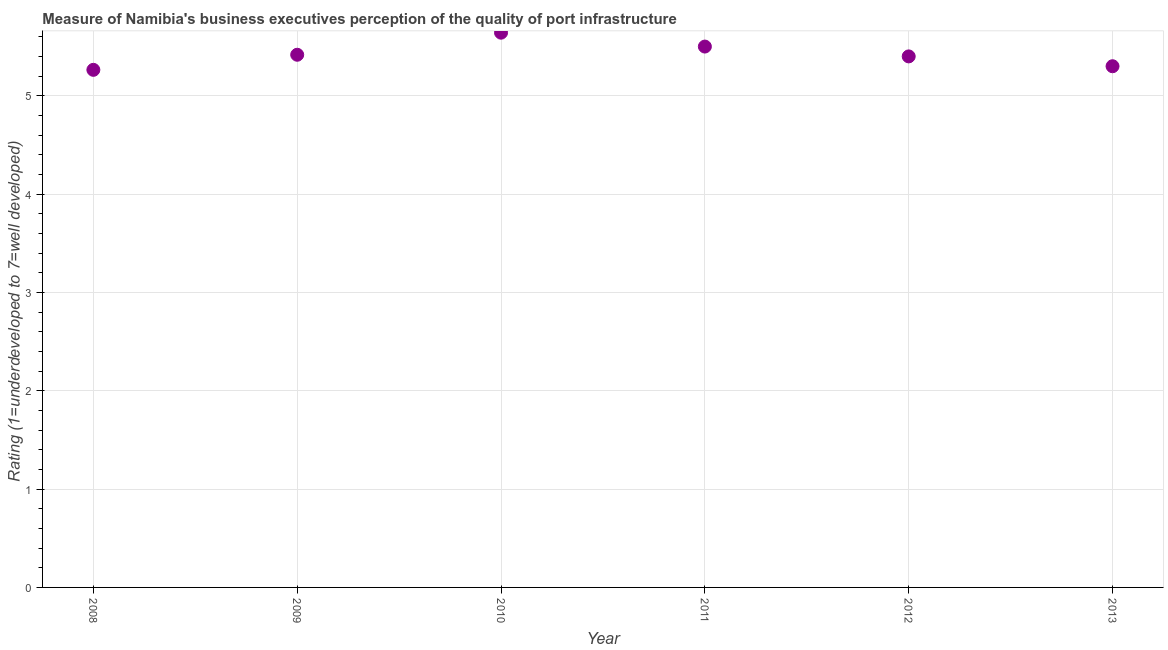What is the rating measuring quality of port infrastructure in 2009?
Ensure brevity in your answer.  5.42. Across all years, what is the maximum rating measuring quality of port infrastructure?
Your response must be concise. 5.64. Across all years, what is the minimum rating measuring quality of port infrastructure?
Your answer should be compact. 5.26. In which year was the rating measuring quality of port infrastructure maximum?
Keep it short and to the point. 2010. In which year was the rating measuring quality of port infrastructure minimum?
Offer a very short reply. 2008. What is the sum of the rating measuring quality of port infrastructure?
Your answer should be compact. 32.52. What is the difference between the rating measuring quality of port infrastructure in 2010 and 2012?
Your answer should be compact. 0.24. What is the average rating measuring quality of port infrastructure per year?
Provide a succinct answer. 5.42. What is the median rating measuring quality of port infrastructure?
Make the answer very short. 5.41. What is the ratio of the rating measuring quality of port infrastructure in 2008 to that in 2010?
Give a very brief answer. 0.93. Is the difference between the rating measuring quality of port infrastructure in 2010 and 2012 greater than the difference between any two years?
Provide a succinct answer. No. What is the difference between the highest and the second highest rating measuring quality of port infrastructure?
Your answer should be compact. 0.14. What is the difference between the highest and the lowest rating measuring quality of port infrastructure?
Ensure brevity in your answer.  0.38. In how many years, is the rating measuring quality of port infrastructure greater than the average rating measuring quality of port infrastructure taken over all years?
Keep it short and to the point. 2. What is the title of the graph?
Your answer should be very brief. Measure of Namibia's business executives perception of the quality of port infrastructure. What is the label or title of the X-axis?
Ensure brevity in your answer.  Year. What is the label or title of the Y-axis?
Give a very brief answer. Rating (1=underdeveloped to 7=well developed) . What is the Rating (1=underdeveloped to 7=well developed)  in 2008?
Your response must be concise. 5.26. What is the Rating (1=underdeveloped to 7=well developed)  in 2009?
Your answer should be compact. 5.42. What is the Rating (1=underdeveloped to 7=well developed)  in 2010?
Your answer should be compact. 5.64. What is the Rating (1=underdeveloped to 7=well developed)  in 2011?
Offer a terse response. 5.5. What is the Rating (1=underdeveloped to 7=well developed)  in 2012?
Make the answer very short. 5.4. What is the difference between the Rating (1=underdeveloped to 7=well developed)  in 2008 and 2009?
Give a very brief answer. -0.15. What is the difference between the Rating (1=underdeveloped to 7=well developed)  in 2008 and 2010?
Keep it short and to the point. -0.38. What is the difference between the Rating (1=underdeveloped to 7=well developed)  in 2008 and 2011?
Keep it short and to the point. -0.24. What is the difference between the Rating (1=underdeveloped to 7=well developed)  in 2008 and 2012?
Provide a succinct answer. -0.14. What is the difference between the Rating (1=underdeveloped to 7=well developed)  in 2008 and 2013?
Ensure brevity in your answer.  -0.04. What is the difference between the Rating (1=underdeveloped to 7=well developed)  in 2009 and 2010?
Ensure brevity in your answer.  -0.22. What is the difference between the Rating (1=underdeveloped to 7=well developed)  in 2009 and 2011?
Make the answer very short. -0.08. What is the difference between the Rating (1=underdeveloped to 7=well developed)  in 2009 and 2012?
Make the answer very short. 0.02. What is the difference between the Rating (1=underdeveloped to 7=well developed)  in 2009 and 2013?
Offer a terse response. 0.12. What is the difference between the Rating (1=underdeveloped to 7=well developed)  in 2010 and 2011?
Provide a succinct answer. 0.14. What is the difference between the Rating (1=underdeveloped to 7=well developed)  in 2010 and 2012?
Offer a very short reply. 0.24. What is the difference between the Rating (1=underdeveloped to 7=well developed)  in 2010 and 2013?
Make the answer very short. 0.34. What is the difference between the Rating (1=underdeveloped to 7=well developed)  in 2011 and 2013?
Provide a succinct answer. 0.2. What is the ratio of the Rating (1=underdeveloped to 7=well developed)  in 2008 to that in 2009?
Offer a terse response. 0.97. What is the ratio of the Rating (1=underdeveloped to 7=well developed)  in 2008 to that in 2010?
Your answer should be very brief. 0.93. What is the ratio of the Rating (1=underdeveloped to 7=well developed)  in 2008 to that in 2012?
Offer a terse response. 0.97. What is the ratio of the Rating (1=underdeveloped to 7=well developed)  in 2010 to that in 2012?
Provide a succinct answer. 1.04. What is the ratio of the Rating (1=underdeveloped to 7=well developed)  in 2010 to that in 2013?
Make the answer very short. 1.06. What is the ratio of the Rating (1=underdeveloped to 7=well developed)  in 2011 to that in 2012?
Offer a very short reply. 1.02. What is the ratio of the Rating (1=underdeveloped to 7=well developed)  in 2011 to that in 2013?
Offer a terse response. 1.04. What is the ratio of the Rating (1=underdeveloped to 7=well developed)  in 2012 to that in 2013?
Provide a short and direct response. 1.02. 